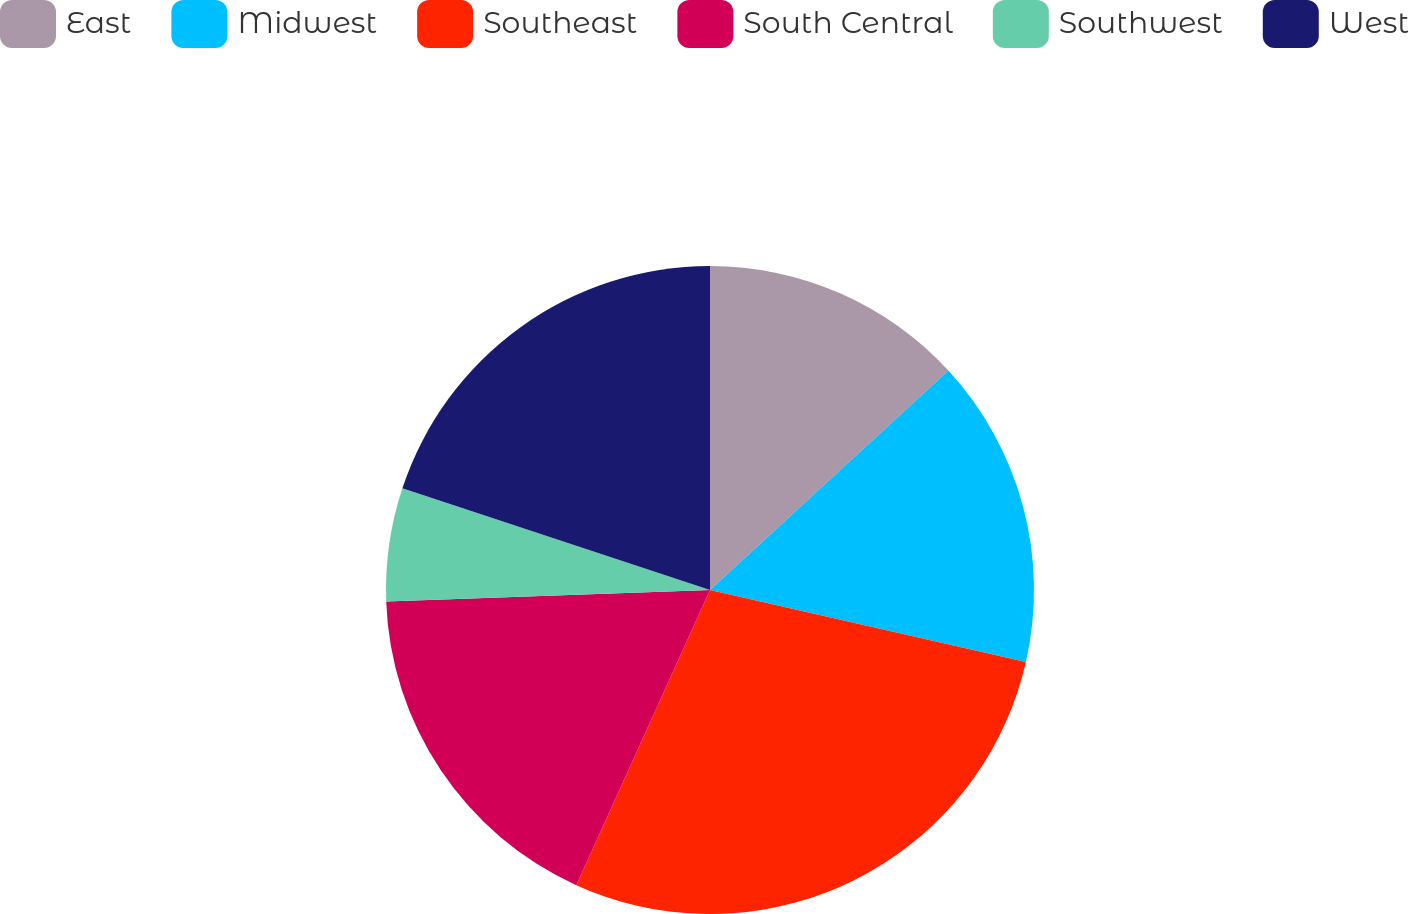Convert chart to OTSL. <chart><loc_0><loc_0><loc_500><loc_500><pie_chart><fcel>East<fcel>Midwest<fcel>Southeast<fcel>South Central<fcel>Southwest<fcel>West<nl><fcel>13.16%<fcel>15.41%<fcel>28.2%<fcel>17.67%<fcel>5.64%<fcel>19.92%<nl></chart> 